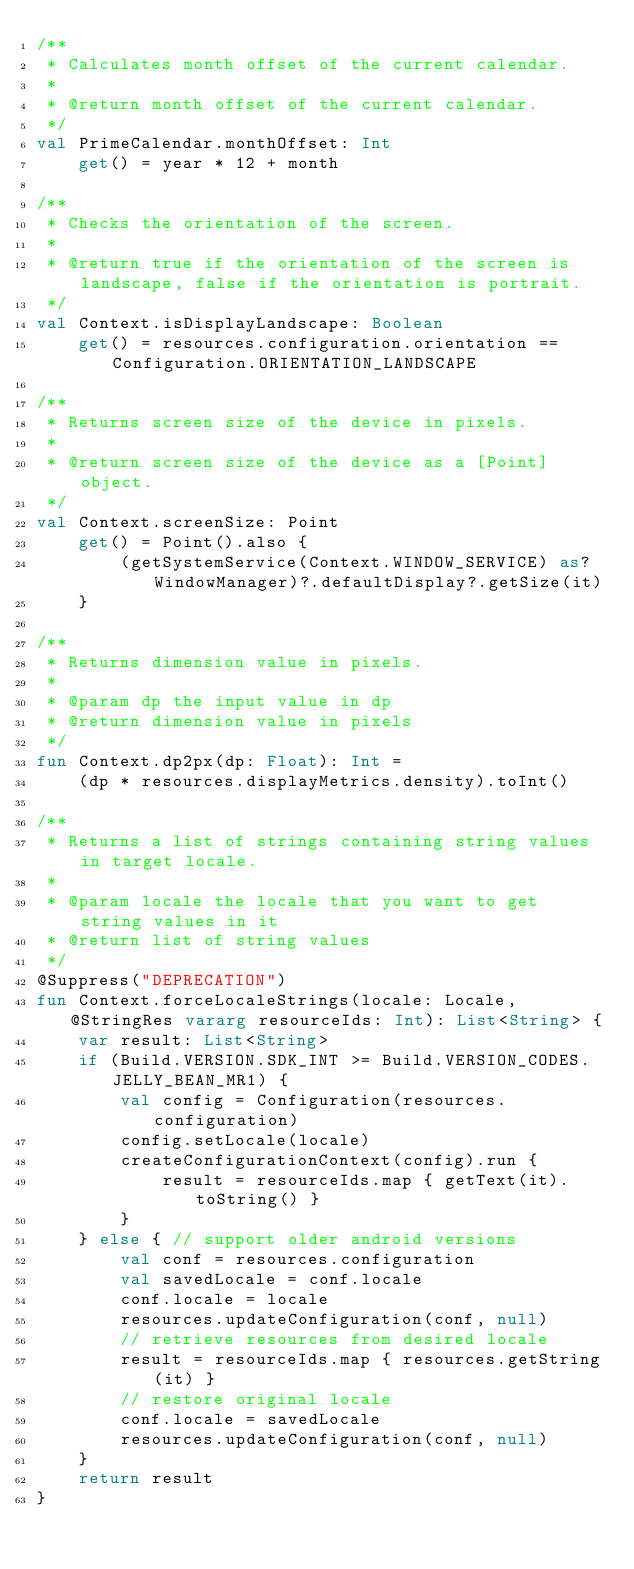Convert code to text. <code><loc_0><loc_0><loc_500><loc_500><_Kotlin_>/**
 * Calculates month offset of the current calendar.
 *
 * @return month offset of the current calendar.
 */
val PrimeCalendar.monthOffset: Int
    get() = year * 12 + month

/**
 * Checks the orientation of the screen.
 *
 * @return true if the orientation of the screen is landscape, false if the orientation is portrait.
 */
val Context.isDisplayLandscape: Boolean
    get() = resources.configuration.orientation == Configuration.ORIENTATION_LANDSCAPE

/**
 * Returns screen size of the device in pixels.
 *
 * @return screen size of the device as a [Point] object.
 */
val Context.screenSize: Point
    get() = Point().also {
        (getSystemService(Context.WINDOW_SERVICE) as? WindowManager)?.defaultDisplay?.getSize(it)
    }

/**
 * Returns dimension value in pixels.
 *
 * @param dp the input value in dp
 * @return dimension value in pixels
 */
fun Context.dp2px(dp: Float): Int =
    (dp * resources.displayMetrics.density).toInt()

/**
 * Returns a list of strings containing string values in target locale.
 *
 * @param locale the locale that you want to get string values in it
 * @return list of string values
 */
@Suppress("DEPRECATION")
fun Context.forceLocaleStrings(locale: Locale, @StringRes vararg resourceIds: Int): List<String> {
    var result: List<String>
    if (Build.VERSION.SDK_INT >= Build.VERSION_CODES.JELLY_BEAN_MR1) {
        val config = Configuration(resources.configuration)
        config.setLocale(locale)
        createConfigurationContext(config).run {
            result = resourceIds.map { getText(it).toString() }
        }
    } else { // support older android versions
        val conf = resources.configuration
        val savedLocale = conf.locale
        conf.locale = locale
        resources.updateConfiguration(conf, null)
        // retrieve resources from desired locale
        result = resourceIds.map { resources.getString(it) }
        // restore original locale
        conf.locale = savedLocale
        resources.updateConfiguration(conf, null)
    }
    return result
}
</code> 